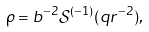<formula> <loc_0><loc_0><loc_500><loc_500>\rho = b ^ { - 2 } \mathcal { S } ^ { ( - 1 ) } ( q r ^ { - 2 } ) ,</formula> 